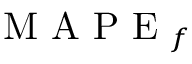Convert formula to latex. <formula><loc_0><loc_0><loc_500><loc_500>M A P E _ { f }</formula> 